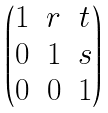Convert formula to latex. <formula><loc_0><loc_0><loc_500><loc_500>\begin{pmatrix} 1 & r & t \\ 0 & 1 & s \\ 0 & 0 & 1 \end{pmatrix}</formula> 